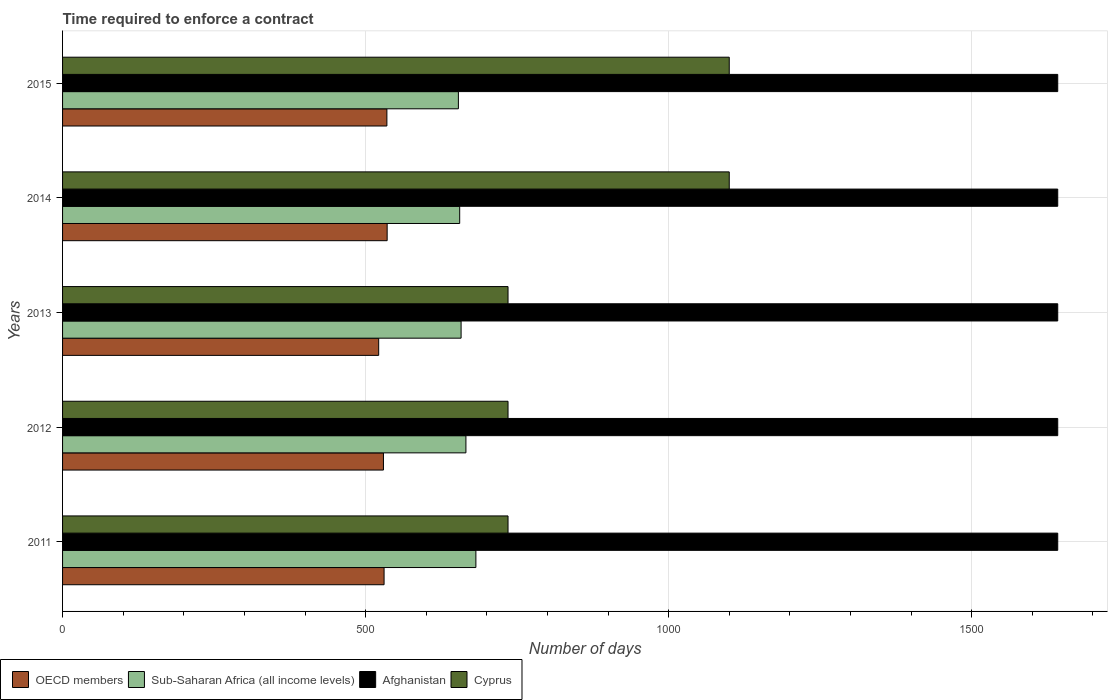How many different coloured bars are there?
Your answer should be very brief. 4. Are the number of bars per tick equal to the number of legend labels?
Your answer should be compact. Yes. How many bars are there on the 2nd tick from the top?
Your answer should be very brief. 4. What is the label of the 1st group of bars from the top?
Offer a very short reply. 2015. In how many cases, is the number of bars for a given year not equal to the number of legend labels?
Provide a succinct answer. 0. What is the number of days required to enforce a contract in OECD members in 2014?
Ensure brevity in your answer.  535.56. Across all years, what is the maximum number of days required to enforce a contract in OECD members?
Your response must be concise. 535.56. Across all years, what is the minimum number of days required to enforce a contract in Cyprus?
Make the answer very short. 735. In which year was the number of days required to enforce a contract in Afghanistan maximum?
Offer a terse response. 2011. What is the total number of days required to enforce a contract in Sub-Saharan Africa (all income levels) in the graph?
Make the answer very short. 3313.4. What is the difference between the number of days required to enforce a contract in Afghanistan in 2012 and that in 2013?
Keep it short and to the point. 0. What is the difference between the number of days required to enforce a contract in Cyprus in 2013 and the number of days required to enforce a contract in Afghanistan in 2012?
Your response must be concise. -907. What is the average number of days required to enforce a contract in Afghanistan per year?
Your answer should be compact. 1642. In the year 2011, what is the difference between the number of days required to enforce a contract in Sub-Saharan Africa (all income levels) and number of days required to enforce a contract in OECD members?
Give a very brief answer. 151.49. What is the ratio of the number of days required to enforce a contract in OECD members in 2013 to that in 2015?
Provide a succinct answer. 0.97. Is the difference between the number of days required to enforce a contract in Sub-Saharan Africa (all income levels) in 2014 and 2015 greater than the difference between the number of days required to enforce a contract in OECD members in 2014 and 2015?
Provide a succinct answer. Yes. What is the difference between the highest and the lowest number of days required to enforce a contract in OECD members?
Give a very brief answer. 13.97. Is the sum of the number of days required to enforce a contract in Afghanistan in 2011 and 2014 greater than the maximum number of days required to enforce a contract in Sub-Saharan Africa (all income levels) across all years?
Your response must be concise. Yes. What does the 1st bar from the top in 2013 represents?
Offer a terse response. Cyprus. What does the 4th bar from the bottom in 2011 represents?
Ensure brevity in your answer.  Cyprus. Is it the case that in every year, the sum of the number of days required to enforce a contract in OECD members and number of days required to enforce a contract in Cyprus is greater than the number of days required to enforce a contract in Afghanistan?
Offer a very short reply. No. How many bars are there?
Provide a short and direct response. 20. Are all the bars in the graph horizontal?
Provide a succinct answer. Yes. Are the values on the major ticks of X-axis written in scientific E-notation?
Provide a short and direct response. No. Does the graph contain grids?
Provide a succinct answer. Yes. How are the legend labels stacked?
Your answer should be very brief. Horizontal. What is the title of the graph?
Make the answer very short. Time required to enforce a contract. What is the label or title of the X-axis?
Offer a very short reply. Number of days. What is the Number of days of OECD members in 2011?
Provide a short and direct response. 530.48. What is the Number of days of Sub-Saharan Africa (all income levels) in 2011?
Provide a succinct answer. 681.98. What is the Number of days of Afghanistan in 2011?
Offer a very short reply. 1642. What is the Number of days of Cyprus in 2011?
Keep it short and to the point. 735. What is the Number of days in OECD members in 2012?
Provide a succinct answer. 529.45. What is the Number of days of Sub-Saharan Africa (all income levels) in 2012?
Provide a short and direct response. 665.52. What is the Number of days of Afghanistan in 2012?
Your response must be concise. 1642. What is the Number of days of Cyprus in 2012?
Make the answer very short. 735. What is the Number of days in OECD members in 2013?
Ensure brevity in your answer.  521.59. What is the Number of days in Sub-Saharan Africa (all income levels) in 2013?
Offer a terse response. 657.57. What is the Number of days in Afghanistan in 2013?
Provide a succinct answer. 1642. What is the Number of days in Cyprus in 2013?
Provide a short and direct response. 735. What is the Number of days in OECD members in 2014?
Your answer should be compact. 535.56. What is the Number of days of Sub-Saharan Africa (all income levels) in 2014?
Provide a short and direct response. 655.23. What is the Number of days of Afghanistan in 2014?
Make the answer very short. 1642. What is the Number of days in Cyprus in 2014?
Provide a succinct answer. 1100. What is the Number of days of OECD members in 2015?
Give a very brief answer. 535.12. What is the Number of days of Sub-Saharan Africa (all income levels) in 2015?
Provide a short and direct response. 653.1. What is the Number of days in Afghanistan in 2015?
Make the answer very short. 1642. What is the Number of days in Cyprus in 2015?
Offer a very short reply. 1100. Across all years, what is the maximum Number of days of OECD members?
Ensure brevity in your answer.  535.56. Across all years, what is the maximum Number of days of Sub-Saharan Africa (all income levels)?
Give a very brief answer. 681.98. Across all years, what is the maximum Number of days in Afghanistan?
Provide a succinct answer. 1642. Across all years, what is the maximum Number of days of Cyprus?
Offer a terse response. 1100. Across all years, what is the minimum Number of days of OECD members?
Provide a succinct answer. 521.59. Across all years, what is the minimum Number of days of Sub-Saharan Africa (all income levels)?
Offer a terse response. 653.1. Across all years, what is the minimum Number of days in Afghanistan?
Your answer should be very brief. 1642. Across all years, what is the minimum Number of days in Cyprus?
Make the answer very short. 735. What is the total Number of days of OECD members in the graph?
Your answer should be compact. 2652.2. What is the total Number of days of Sub-Saharan Africa (all income levels) in the graph?
Ensure brevity in your answer.  3313.4. What is the total Number of days of Afghanistan in the graph?
Offer a very short reply. 8210. What is the total Number of days of Cyprus in the graph?
Keep it short and to the point. 4405. What is the difference between the Number of days of OECD members in 2011 and that in 2012?
Your answer should be very brief. 1.03. What is the difference between the Number of days of Sub-Saharan Africa (all income levels) in 2011 and that in 2012?
Give a very brief answer. 16.46. What is the difference between the Number of days of Afghanistan in 2011 and that in 2012?
Your response must be concise. 0. What is the difference between the Number of days in OECD members in 2011 and that in 2013?
Give a very brief answer. 8.9. What is the difference between the Number of days of Sub-Saharan Africa (all income levels) in 2011 and that in 2013?
Your answer should be very brief. 24.41. What is the difference between the Number of days in Afghanistan in 2011 and that in 2013?
Offer a terse response. 0. What is the difference between the Number of days of Cyprus in 2011 and that in 2013?
Your answer should be very brief. 0. What is the difference between the Number of days of OECD members in 2011 and that in 2014?
Offer a terse response. -5.08. What is the difference between the Number of days of Sub-Saharan Africa (all income levels) in 2011 and that in 2014?
Provide a succinct answer. 26.75. What is the difference between the Number of days of Afghanistan in 2011 and that in 2014?
Give a very brief answer. 0. What is the difference between the Number of days in Cyprus in 2011 and that in 2014?
Your response must be concise. -365. What is the difference between the Number of days of OECD members in 2011 and that in 2015?
Provide a succinct answer. -4.63. What is the difference between the Number of days of Sub-Saharan Africa (all income levels) in 2011 and that in 2015?
Ensure brevity in your answer.  28.88. What is the difference between the Number of days of Cyprus in 2011 and that in 2015?
Give a very brief answer. -365. What is the difference between the Number of days of OECD members in 2012 and that in 2013?
Offer a terse response. 7.86. What is the difference between the Number of days in Sub-Saharan Africa (all income levels) in 2012 and that in 2013?
Provide a succinct answer. 7.95. What is the difference between the Number of days of Cyprus in 2012 and that in 2013?
Your answer should be very brief. 0. What is the difference between the Number of days in OECD members in 2012 and that in 2014?
Keep it short and to the point. -6.11. What is the difference between the Number of days of Sub-Saharan Africa (all income levels) in 2012 and that in 2014?
Offer a terse response. 10.29. What is the difference between the Number of days of Cyprus in 2012 and that in 2014?
Offer a terse response. -365. What is the difference between the Number of days in OECD members in 2012 and that in 2015?
Your response must be concise. -5.67. What is the difference between the Number of days of Sub-Saharan Africa (all income levels) in 2012 and that in 2015?
Provide a short and direct response. 12.42. What is the difference between the Number of days in Afghanistan in 2012 and that in 2015?
Your response must be concise. 0. What is the difference between the Number of days in Cyprus in 2012 and that in 2015?
Your answer should be compact. -365. What is the difference between the Number of days of OECD members in 2013 and that in 2014?
Provide a short and direct response. -13.97. What is the difference between the Number of days in Sub-Saharan Africa (all income levels) in 2013 and that in 2014?
Keep it short and to the point. 2.34. What is the difference between the Number of days in Cyprus in 2013 and that in 2014?
Ensure brevity in your answer.  -365. What is the difference between the Number of days in OECD members in 2013 and that in 2015?
Offer a very short reply. -13.53. What is the difference between the Number of days of Sub-Saharan Africa (all income levels) in 2013 and that in 2015?
Ensure brevity in your answer.  4.47. What is the difference between the Number of days in Afghanistan in 2013 and that in 2015?
Give a very brief answer. 0. What is the difference between the Number of days of Cyprus in 2013 and that in 2015?
Provide a succinct answer. -365. What is the difference between the Number of days of OECD members in 2014 and that in 2015?
Your answer should be compact. 0.44. What is the difference between the Number of days of Sub-Saharan Africa (all income levels) in 2014 and that in 2015?
Provide a succinct answer. 2.13. What is the difference between the Number of days of Afghanistan in 2014 and that in 2015?
Give a very brief answer. 0. What is the difference between the Number of days of Cyprus in 2014 and that in 2015?
Provide a succinct answer. 0. What is the difference between the Number of days of OECD members in 2011 and the Number of days of Sub-Saharan Africa (all income levels) in 2012?
Provide a short and direct response. -135.04. What is the difference between the Number of days of OECD members in 2011 and the Number of days of Afghanistan in 2012?
Provide a succinct answer. -1111.52. What is the difference between the Number of days in OECD members in 2011 and the Number of days in Cyprus in 2012?
Your response must be concise. -204.52. What is the difference between the Number of days of Sub-Saharan Africa (all income levels) in 2011 and the Number of days of Afghanistan in 2012?
Your answer should be very brief. -960.02. What is the difference between the Number of days of Sub-Saharan Africa (all income levels) in 2011 and the Number of days of Cyprus in 2012?
Offer a very short reply. -53.02. What is the difference between the Number of days in Afghanistan in 2011 and the Number of days in Cyprus in 2012?
Offer a terse response. 907. What is the difference between the Number of days in OECD members in 2011 and the Number of days in Sub-Saharan Africa (all income levels) in 2013?
Your answer should be very brief. -127.09. What is the difference between the Number of days in OECD members in 2011 and the Number of days in Afghanistan in 2013?
Your answer should be very brief. -1111.52. What is the difference between the Number of days of OECD members in 2011 and the Number of days of Cyprus in 2013?
Give a very brief answer. -204.52. What is the difference between the Number of days in Sub-Saharan Africa (all income levels) in 2011 and the Number of days in Afghanistan in 2013?
Offer a very short reply. -960.02. What is the difference between the Number of days of Sub-Saharan Africa (all income levels) in 2011 and the Number of days of Cyprus in 2013?
Your response must be concise. -53.02. What is the difference between the Number of days in Afghanistan in 2011 and the Number of days in Cyprus in 2013?
Provide a succinct answer. 907. What is the difference between the Number of days in OECD members in 2011 and the Number of days in Sub-Saharan Africa (all income levels) in 2014?
Offer a terse response. -124.75. What is the difference between the Number of days of OECD members in 2011 and the Number of days of Afghanistan in 2014?
Provide a succinct answer. -1111.52. What is the difference between the Number of days of OECD members in 2011 and the Number of days of Cyprus in 2014?
Give a very brief answer. -569.52. What is the difference between the Number of days in Sub-Saharan Africa (all income levels) in 2011 and the Number of days in Afghanistan in 2014?
Offer a terse response. -960.02. What is the difference between the Number of days of Sub-Saharan Africa (all income levels) in 2011 and the Number of days of Cyprus in 2014?
Offer a terse response. -418.02. What is the difference between the Number of days in Afghanistan in 2011 and the Number of days in Cyprus in 2014?
Make the answer very short. 542. What is the difference between the Number of days of OECD members in 2011 and the Number of days of Sub-Saharan Africa (all income levels) in 2015?
Offer a terse response. -122.62. What is the difference between the Number of days of OECD members in 2011 and the Number of days of Afghanistan in 2015?
Offer a terse response. -1111.52. What is the difference between the Number of days of OECD members in 2011 and the Number of days of Cyprus in 2015?
Provide a short and direct response. -569.52. What is the difference between the Number of days in Sub-Saharan Africa (all income levels) in 2011 and the Number of days in Afghanistan in 2015?
Offer a very short reply. -960.02. What is the difference between the Number of days in Sub-Saharan Africa (all income levels) in 2011 and the Number of days in Cyprus in 2015?
Provide a short and direct response. -418.02. What is the difference between the Number of days in Afghanistan in 2011 and the Number of days in Cyprus in 2015?
Make the answer very short. 542. What is the difference between the Number of days of OECD members in 2012 and the Number of days of Sub-Saharan Africa (all income levels) in 2013?
Your answer should be compact. -128.12. What is the difference between the Number of days in OECD members in 2012 and the Number of days in Afghanistan in 2013?
Offer a very short reply. -1112.55. What is the difference between the Number of days of OECD members in 2012 and the Number of days of Cyprus in 2013?
Give a very brief answer. -205.55. What is the difference between the Number of days in Sub-Saharan Africa (all income levels) in 2012 and the Number of days in Afghanistan in 2013?
Ensure brevity in your answer.  -976.48. What is the difference between the Number of days of Sub-Saharan Africa (all income levels) in 2012 and the Number of days of Cyprus in 2013?
Your answer should be very brief. -69.48. What is the difference between the Number of days in Afghanistan in 2012 and the Number of days in Cyprus in 2013?
Your answer should be very brief. 907. What is the difference between the Number of days of OECD members in 2012 and the Number of days of Sub-Saharan Africa (all income levels) in 2014?
Give a very brief answer. -125.78. What is the difference between the Number of days of OECD members in 2012 and the Number of days of Afghanistan in 2014?
Offer a terse response. -1112.55. What is the difference between the Number of days in OECD members in 2012 and the Number of days in Cyprus in 2014?
Make the answer very short. -570.55. What is the difference between the Number of days of Sub-Saharan Africa (all income levels) in 2012 and the Number of days of Afghanistan in 2014?
Your answer should be very brief. -976.48. What is the difference between the Number of days of Sub-Saharan Africa (all income levels) in 2012 and the Number of days of Cyprus in 2014?
Keep it short and to the point. -434.48. What is the difference between the Number of days of Afghanistan in 2012 and the Number of days of Cyprus in 2014?
Your response must be concise. 542. What is the difference between the Number of days of OECD members in 2012 and the Number of days of Sub-Saharan Africa (all income levels) in 2015?
Offer a very short reply. -123.65. What is the difference between the Number of days of OECD members in 2012 and the Number of days of Afghanistan in 2015?
Keep it short and to the point. -1112.55. What is the difference between the Number of days of OECD members in 2012 and the Number of days of Cyprus in 2015?
Provide a short and direct response. -570.55. What is the difference between the Number of days of Sub-Saharan Africa (all income levels) in 2012 and the Number of days of Afghanistan in 2015?
Offer a very short reply. -976.48. What is the difference between the Number of days of Sub-Saharan Africa (all income levels) in 2012 and the Number of days of Cyprus in 2015?
Ensure brevity in your answer.  -434.48. What is the difference between the Number of days of Afghanistan in 2012 and the Number of days of Cyprus in 2015?
Keep it short and to the point. 542. What is the difference between the Number of days in OECD members in 2013 and the Number of days in Sub-Saharan Africa (all income levels) in 2014?
Keep it short and to the point. -133.64. What is the difference between the Number of days in OECD members in 2013 and the Number of days in Afghanistan in 2014?
Offer a very short reply. -1120.41. What is the difference between the Number of days of OECD members in 2013 and the Number of days of Cyprus in 2014?
Ensure brevity in your answer.  -578.41. What is the difference between the Number of days in Sub-Saharan Africa (all income levels) in 2013 and the Number of days in Afghanistan in 2014?
Your response must be concise. -984.43. What is the difference between the Number of days in Sub-Saharan Africa (all income levels) in 2013 and the Number of days in Cyprus in 2014?
Provide a short and direct response. -442.43. What is the difference between the Number of days in Afghanistan in 2013 and the Number of days in Cyprus in 2014?
Your response must be concise. 542. What is the difference between the Number of days of OECD members in 2013 and the Number of days of Sub-Saharan Africa (all income levels) in 2015?
Offer a terse response. -131.51. What is the difference between the Number of days of OECD members in 2013 and the Number of days of Afghanistan in 2015?
Ensure brevity in your answer.  -1120.41. What is the difference between the Number of days in OECD members in 2013 and the Number of days in Cyprus in 2015?
Offer a very short reply. -578.41. What is the difference between the Number of days in Sub-Saharan Africa (all income levels) in 2013 and the Number of days in Afghanistan in 2015?
Your response must be concise. -984.43. What is the difference between the Number of days of Sub-Saharan Africa (all income levels) in 2013 and the Number of days of Cyprus in 2015?
Your answer should be compact. -442.43. What is the difference between the Number of days in Afghanistan in 2013 and the Number of days in Cyprus in 2015?
Provide a succinct answer. 542. What is the difference between the Number of days of OECD members in 2014 and the Number of days of Sub-Saharan Africa (all income levels) in 2015?
Ensure brevity in your answer.  -117.54. What is the difference between the Number of days of OECD members in 2014 and the Number of days of Afghanistan in 2015?
Your response must be concise. -1106.44. What is the difference between the Number of days in OECD members in 2014 and the Number of days in Cyprus in 2015?
Ensure brevity in your answer.  -564.44. What is the difference between the Number of days in Sub-Saharan Africa (all income levels) in 2014 and the Number of days in Afghanistan in 2015?
Your answer should be compact. -986.77. What is the difference between the Number of days in Sub-Saharan Africa (all income levels) in 2014 and the Number of days in Cyprus in 2015?
Offer a terse response. -444.77. What is the difference between the Number of days of Afghanistan in 2014 and the Number of days of Cyprus in 2015?
Ensure brevity in your answer.  542. What is the average Number of days of OECD members per year?
Ensure brevity in your answer.  530.44. What is the average Number of days in Sub-Saharan Africa (all income levels) per year?
Your answer should be compact. 662.68. What is the average Number of days of Afghanistan per year?
Provide a short and direct response. 1642. What is the average Number of days in Cyprus per year?
Provide a short and direct response. 881. In the year 2011, what is the difference between the Number of days of OECD members and Number of days of Sub-Saharan Africa (all income levels)?
Make the answer very short. -151.49. In the year 2011, what is the difference between the Number of days of OECD members and Number of days of Afghanistan?
Your response must be concise. -1111.52. In the year 2011, what is the difference between the Number of days in OECD members and Number of days in Cyprus?
Ensure brevity in your answer.  -204.52. In the year 2011, what is the difference between the Number of days of Sub-Saharan Africa (all income levels) and Number of days of Afghanistan?
Ensure brevity in your answer.  -960.02. In the year 2011, what is the difference between the Number of days in Sub-Saharan Africa (all income levels) and Number of days in Cyprus?
Make the answer very short. -53.02. In the year 2011, what is the difference between the Number of days in Afghanistan and Number of days in Cyprus?
Give a very brief answer. 907. In the year 2012, what is the difference between the Number of days in OECD members and Number of days in Sub-Saharan Africa (all income levels)?
Your answer should be compact. -136.07. In the year 2012, what is the difference between the Number of days in OECD members and Number of days in Afghanistan?
Make the answer very short. -1112.55. In the year 2012, what is the difference between the Number of days of OECD members and Number of days of Cyprus?
Offer a very short reply. -205.55. In the year 2012, what is the difference between the Number of days of Sub-Saharan Africa (all income levels) and Number of days of Afghanistan?
Your answer should be very brief. -976.48. In the year 2012, what is the difference between the Number of days in Sub-Saharan Africa (all income levels) and Number of days in Cyprus?
Your answer should be compact. -69.48. In the year 2012, what is the difference between the Number of days of Afghanistan and Number of days of Cyprus?
Offer a terse response. 907. In the year 2013, what is the difference between the Number of days in OECD members and Number of days in Sub-Saharan Africa (all income levels)?
Ensure brevity in your answer.  -135.98. In the year 2013, what is the difference between the Number of days in OECD members and Number of days in Afghanistan?
Offer a very short reply. -1120.41. In the year 2013, what is the difference between the Number of days in OECD members and Number of days in Cyprus?
Keep it short and to the point. -213.41. In the year 2013, what is the difference between the Number of days in Sub-Saharan Africa (all income levels) and Number of days in Afghanistan?
Ensure brevity in your answer.  -984.43. In the year 2013, what is the difference between the Number of days in Sub-Saharan Africa (all income levels) and Number of days in Cyprus?
Your answer should be compact. -77.43. In the year 2013, what is the difference between the Number of days of Afghanistan and Number of days of Cyprus?
Your answer should be compact. 907. In the year 2014, what is the difference between the Number of days in OECD members and Number of days in Sub-Saharan Africa (all income levels)?
Your response must be concise. -119.67. In the year 2014, what is the difference between the Number of days in OECD members and Number of days in Afghanistan?
Provide a succinct answer. -1106.44. In the year 2014, what is the difference between the Number of days of OECD members and Number of days of Cyprus?
Your answer should be very brief. -564.44. In the year 2014, what is the difference between the Number of days of Sub-Saharan Africa (all income levels) and Number of days of Afghanistan?
Give a very brief answer. -986.77. In the year 2014, what is the difference between the Number of days in Sub-Saharan Africa (all income levels) and Number of days in Cyprus?
Your response must be concise. -444.77. In the year 2014, what is the difference between the Number of days in Afghanistan and Number of days in Cyprus?
Give a very brief answer. 542. In the year 2015, what is the difference between the Number of days in OECD members and Number of days in Sub-Saharan Africa (all income levels)?
Ensure brevity in your answer.  -117.98. In the year 2015, what is the difference between the Number of days of OECD members and Number of days of Afghanistan?
Offer a terse response. -1106.88. In the year 2015, what is the difference between the Number of days in OECD members and Number of days in Cyprus?
Your answer should be very brief. -564.88. In the year 2015, what is the difference between the Number of days in Sub-Saharan Africa (all income levels) and Number of days in Afghanistan?
Offer a terse response. -988.9. In the year 2015, what is the difference between the Number of days of Sub-Saharan Africa (all income levels) and Number of days of Cyprus?
Your response must be concise. -446.9. In the year 2015, what is the difference between the Number of days in Afghanistan and Number of days in Cyprus?
Your answer should be compact. 542. What is the ratio of the Number of days of Sub-Saharan Africa (all income levels) in 2011 to that in 2012?
Offer a terse response. 1.02. What is the ratio of the Number of days of Afghanistan in 2011 to that in 2012?
Your answer should be very brief. 1. What is the ratio of the Number of days of OECD members in 2011 to that in 2013?
Provide a short and direct response. 1.02. What is the ratio of the Number of days of Sub-Saharan Africa (all income levels) in 2011 to that in 2013?
Provide a short and direct response. 1.04. What is the ratio of the Number of days of Afghanistan in 2011 to that in 2013?
Your answer should be compact. 1. What is the ratio of the Number of days in OECD members in 2011 to that in 2014?
Your response must be concise. 0.99. What is the ratio of the Number of days in Sub-Saharan Africa (all income levels) in 2011 to that in 2014?
Ensure brevity in your answer.  1.04. What is the ratio of the Number of days in Cyprus in 2011 to that in 2014?
Provide a short and direct response. 0.67. What is the ratio of the Number of days in Sub-Saharan Africa (all income levels) in 2011 to that in 2015?
Keep it short and to the point. 1.04. What is the ratio of the Number of days in Afghanistan in 2011 to that in 2015?
Make the answer very short. 1. What is the ratio of the Number of days in Cyprus in 2011 to that in 2015?
Your answer should be compact. 0.67. What is the ratio of the Number of days of OECD members in 2012 to that in 2013?
Provide a short and direct response. 1.02. What is the ratio of the Number of days of Sub-Saharan Africa (all income levels) in 2012 to that in 2013?
Offer a terse response. 1.01. What is the ratio of the Number of days of Afghanistan in 2012 to that in 2013?
Give a very brief answer. 1. What is the ratio of the Number of days of Cyprus in 2012 to that in 2013?
Keep it short and to the point. 1. What is the ratio of the Number of days of Sub-Saharan Africa (all income levels) in 2012 to that in 2014?
Make the answer very short. 1.02. What is the ratio of the Number of days of Afghanistan in 2012 to that in 2014?
Keep it short and to the point. 1. What is the ratio of the Number of days in Cyprus in 2012 to that in 2014?
Keep it short and to the point. 0.67. What is the ratio of the Number of days of OECD members in 2012 to that in 2015?
Offer a very short reply. 0.99. What is the ratio of the Number of days in Afghanistan in 2012 to that in 2015?
Your response must be concise. 1. What is the ratio of the Number of days in Cyprus in 2012 to that in 2015?
Ensure brevity in your answer.  0.67. What is the ratio of the Number of days of OECD members in 2013 to that in 2014?
Ensure brevity in your answer.  0.97. What is the ratio of the Number of days in Cyprus in 2013 to that in 2014?
Your response must be concise. 0.67. What is the ratio of the Number of days of OECD members in 2013 to that in 2015?
Offer a very short reply. 0.97. What is the ratio of the Number of days in Sub-Saharan Africa (all income levels) in 2013 to that in 2015?
Your answer should be compact. 1.01. What is the ratio of the Number of days of Cyprus in 2013 to that in 2015?
Provide a short and direct response. 0.67. What is the ratio of the Number of days in OECD members in 2014 to that in 2015?
Make the answer very short. 1. What is the ratio of the Number of days of Afghanistan in 2014 to that in 2015?
Offer a terse response. 1. What is the ratio of the Number of days of Cyprus in 2014 to that in 2015?
Your answer should be compact. 1. What is the difference between the highest and the second highest Number of days in OECD members?
Provide a short and direct response. 0.44. What is the difference between the highest and the second highest Number of days of Sub-Saharan Africa (all income levels)?
Offer a terse response. 16.46. What is the difference between the highest and the second highest Number of days in Afghanistan?
Provide a succinct answer. 0. What is the difference between the highest and the second highest Number of days of Cyprus?
Your response must be concise. 0. What is the difference between the highest and the lowest Number of days in OECD members?
Provide a short and direct response. 13.97. What is the difference between the highest and the lowest Number of days of Sub-Saharan Africa (all income levels)?
Provide a succinct answer. 28.88. What is the difference between the highest and the lowest Number of days in Cyprus?
Your response must be concise. 365. 